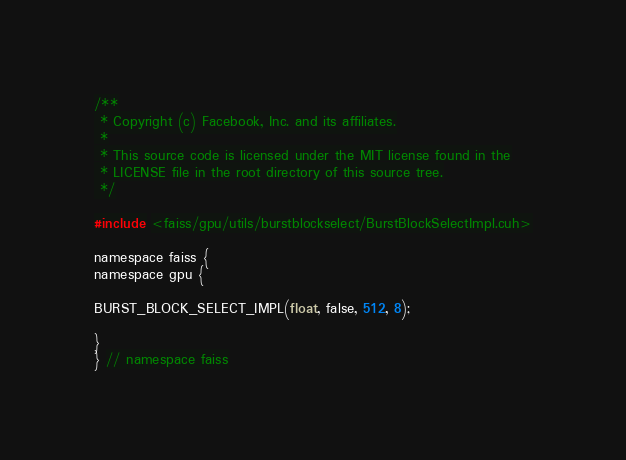Convert code to text. <code><loc_0><loc_0><loc_500><loc_500><_Cuda_>/**
 * Copyright (c) Facebook, Inc. and its affiliates.
 *
 * This source code is licensed under the MIT license found in the
 * LICENSE file in the root directory of this source tree.
 */

#include <faiss/gpu/utils/burstblockselect/BurstBlockSelectImpl.cuh>

namespace faiss {
namespace gpu {

BURST_BLOCK_SELECT_IMPL(float, false, 512, 8);

}
} // namespace faiss
</code> 